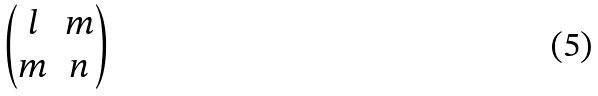<formula> <loc_0><loc_0><loc_500><loc_500>\begin{pmatrix} l & m \\ m & n \\ \end{pmatrix}</formula> 